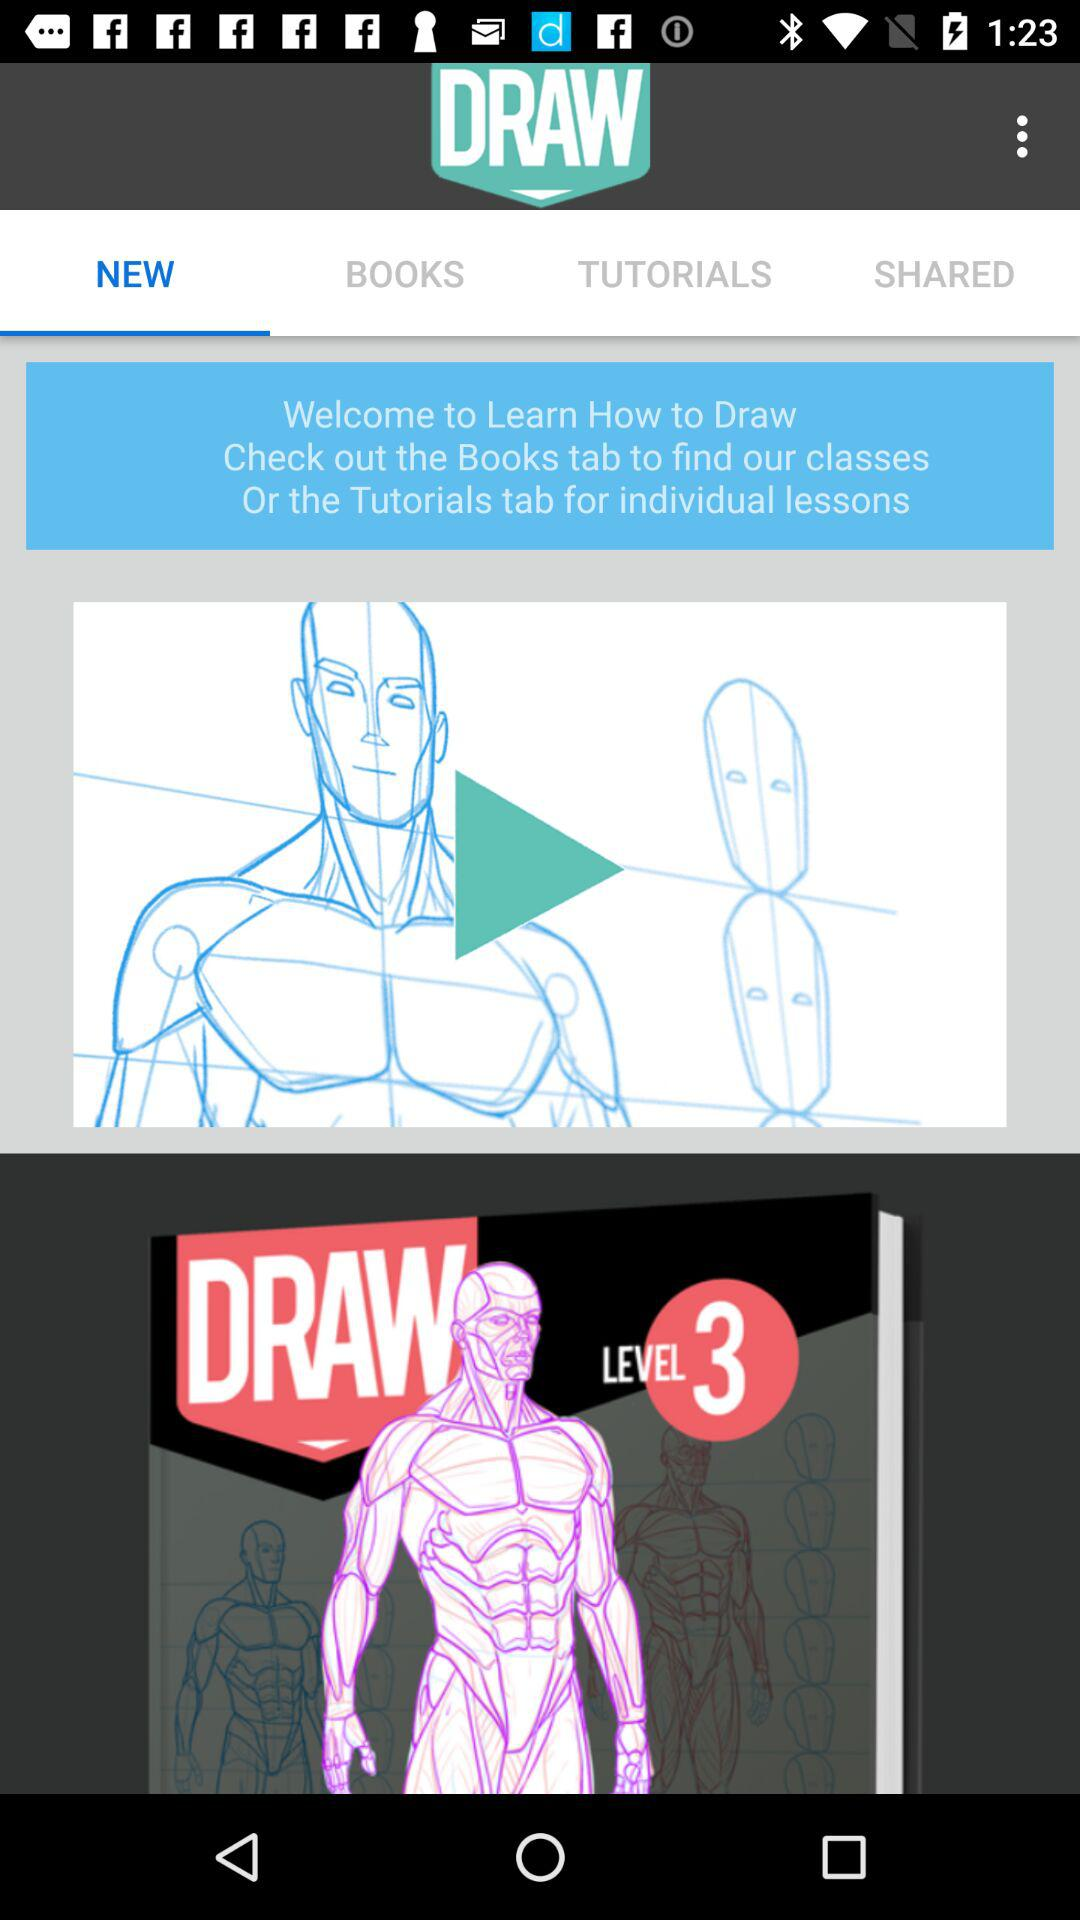What is the selected tab? The selected tab is "NEW". 